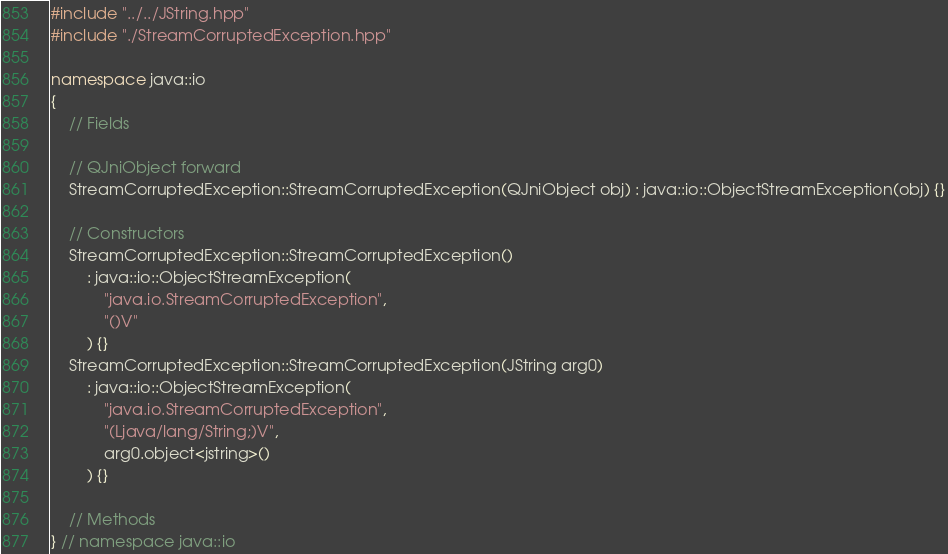<code> <loc_0><loc_0><loc_500><loc_500><_C++_>#include "../../JString.hpp"
#include "./StreamCorruptedException.hpp"

namespace java::io
{
	// Fields
	
	// QJniObject forward
	StreamCorruptedException::StreamCorruptedException(QJniObject obj) : java::io::ObjectStreamException(obj) {}
	
	// Constructors
	StreamCorruptedException::StreamCorruptedException()
		: java::io::ObjectStreamException(
			"java.io.StreamCorruptedException",
			"()V"
		) {}
	StreamCorruptedException::StreamCorruptedException(JString arg0)
		: java::io::ObjectStreamException(
			"java.io.StreamCorruptedException",
			"(Ljava/lang/String;)V",
			arg0.object<jstring>()
		) {}
	
	// Methods
} // namespace java::io

</code> 